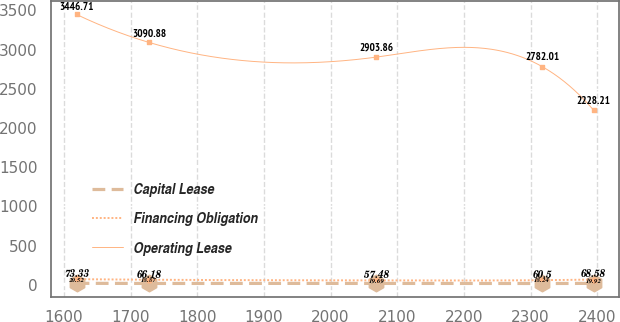<chart> <loc_0><loc_0><loc_500><loc_500><line_chart><ecel><fcel>Capital Lease<fcel>Financing Obligation<fcel>Operating Lease<nl><fcel>1618.93<fcel>20.52<fcel>73.33<fcel>3446.71<nl><fcel>1727.45<fcel>18.87<fcel>66.18<fcel>3090.88<nl><fcel>2068.76<fcel>19.69<fcel>57.48<fcel>2903.86<nl><fcel>2317.49<fcel>18.24<fcel>60.5<fcel>2782.01<nl><fcel>2394.45<fcel>19.92<fcel>68.58<fcel>2228.21<nl></chart> 